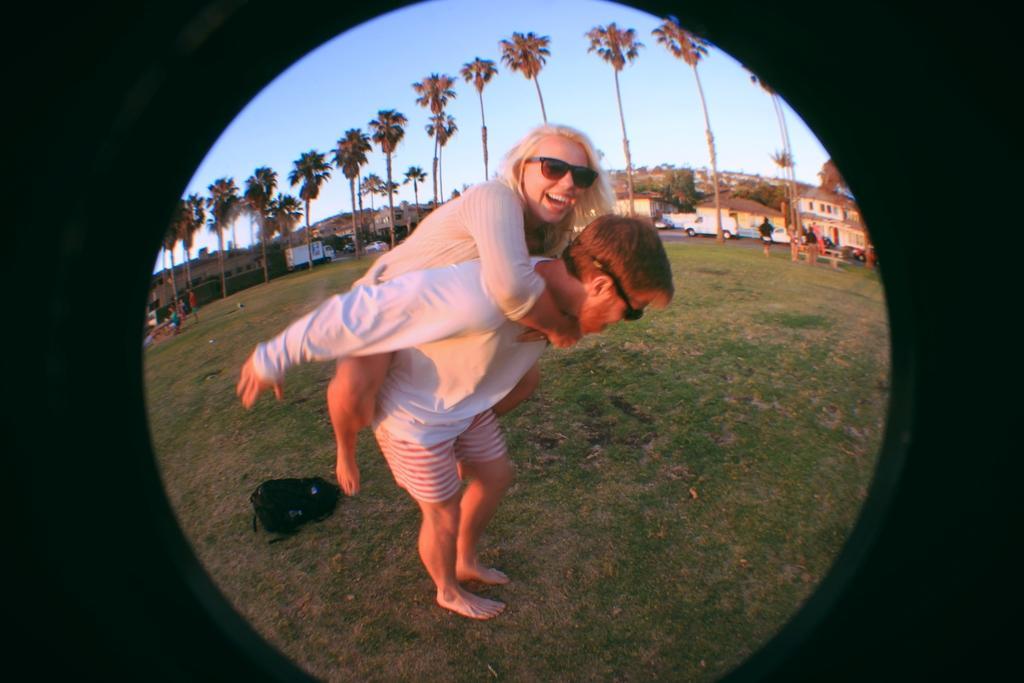Can you describe this image briefly? In this picture I can see a person holding the lady, behind there are some trees, houses and vehicles on the road. 